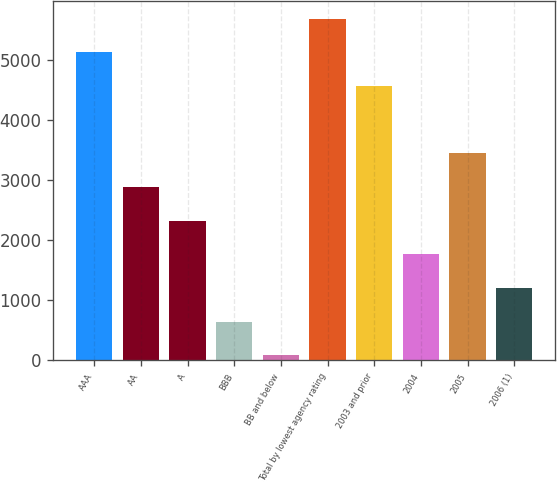Convert chart to OTSL. <chart><loc_0><loc_0><loc_500><loc_500><bar_chart><fcel>AAA<fcel>AA<fcel>A<fcel>BBB<fcel>BB and below<fcel>Total by lowest agency rating<fcel>2003 and prior<fcel>2004<fcel>2005<fcel>2006 (1)<nl><fcel>5125.37<fcel>2885.65<fcel>2325.72<fcel>645.93<fcel>86<fcel>5685.3<fcel>4565.44<fcel>1765.79<fcel>3445.58<fcel>1205.86<nl></chart> 